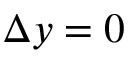Convert formula to latex. <formula><loc_0><loc_0><loc_500><loc_500>\Delta y = 0</formula> 